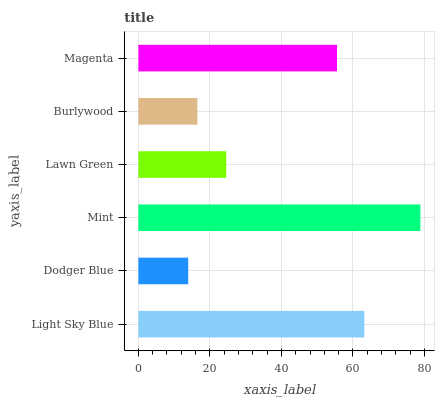Is Dodger Blue the minimum?
Answer yes or no. Yes. Is Mint the maximum?
Answer yes or no. Yes. Is Mint the minimum?
Answer yes or no. No. Is Dodger Blue the maximum?
Answer yes or no. No. Is Mint greater than Dodger Blue?
Answer yes or no. Yes. Is Dodger Blue less than Mint?
Answer yes or no. Yes. Is Dodger Blue greater than Mint?
Answer yes or no. No. Is Mint less than Dodger Blue?
Answer yes or no. No. Is Magenta the high median?
Answer yes or no. Yes. Is Lawn Green the low median?
Answer yes or no. Yes. Is Mint the high median?
Answer yes or no. No. Is Light Sky Blue the low median?
Answer yes or no. No. 